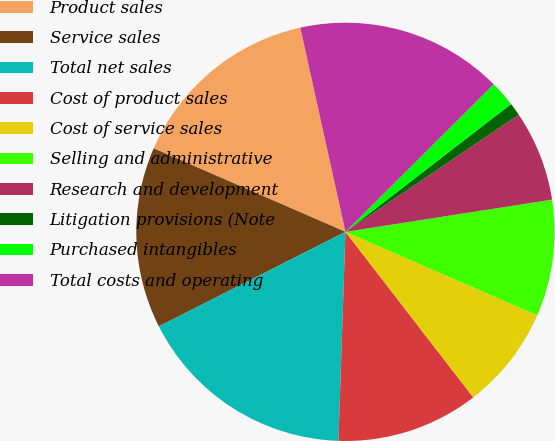<chart> <loc_0><loc_0><loc_500><loc_500><pie_chart><fcel>Product sales<fcel>Service sales<fcel>Total net sales<fcel>Cost of product sales<fcel>Cost of service sales<fcel>Selling and administrative<fcel>Research and development<fcel>Litigation provisions (Note<fcel>Purchased intangibles<fcel>Total costs and operating<nl><fcel>15.0%<fcel>14.0%<fcel>17.0%<fcel>11.0%<fcel>8.0%<fcel>9.0%<fcel>7.0%<fcel>1.0%<fcel>2.0%<fcel>16.0%<nl></chart> 